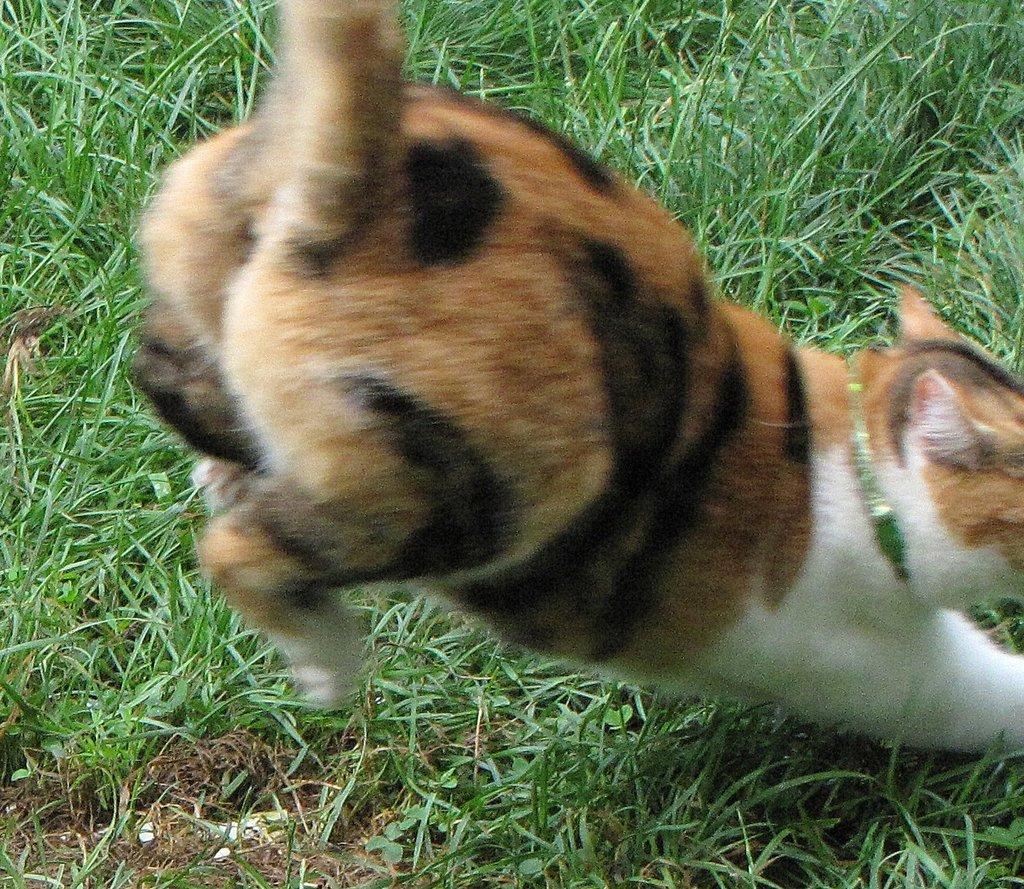In one or two sentences, can you explain what this image depicts? In this image in the center there is one cat, and in the background there is a grass. 